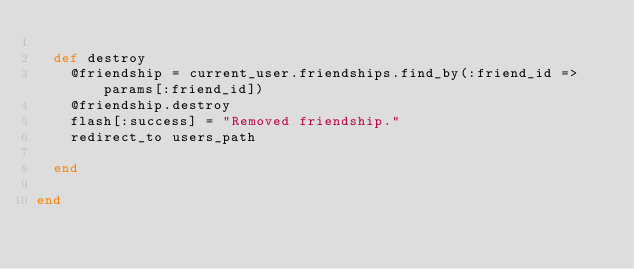<code> <loc_0><loc_0><loc_500><loc_500><_Ruby_>
  def destroy
    @friendship = current_user.friendships.find_by(:friend_id => params[:friend_id])
    @friendship.destroy
    flash[:success] = "Removed friendship."
    redirect_to users_path

  end

end
</code> 